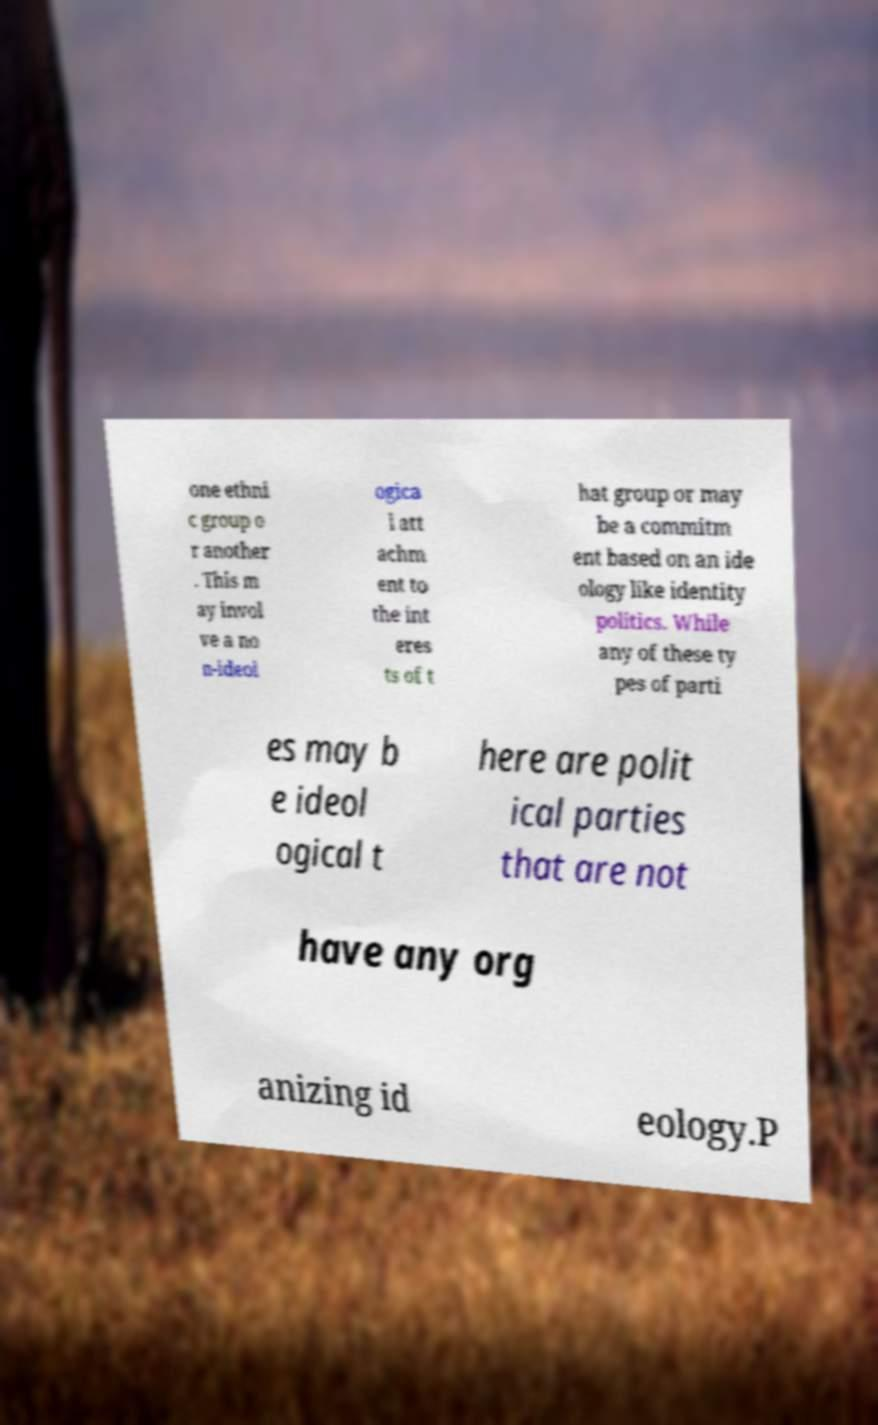For documentation purposes, I need the text within this image transcribed. Could you provide that? one ethni c group o r another . This m ay invol ve a no n-ideol ogica l att achm ent to the int eres ts of t hat group or may be a commitm ent based on an ide ology like identity politics. While any of these ty pes of parti es may b e ideol ogical t here are polit ical parties that are not have any org anizing id eology.P 